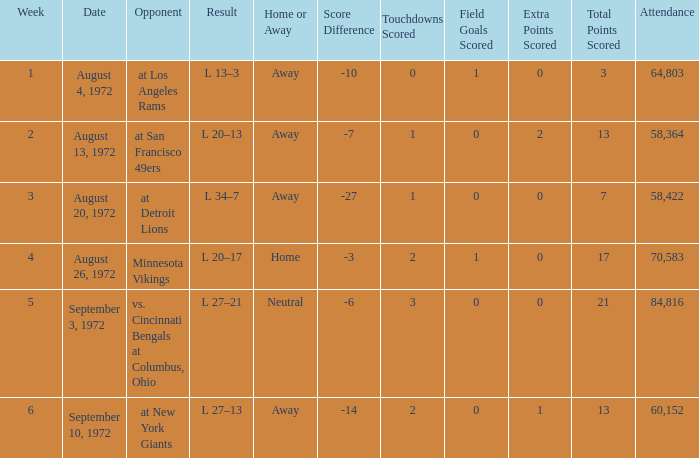What is the date of week 4? August 26, 1972. 